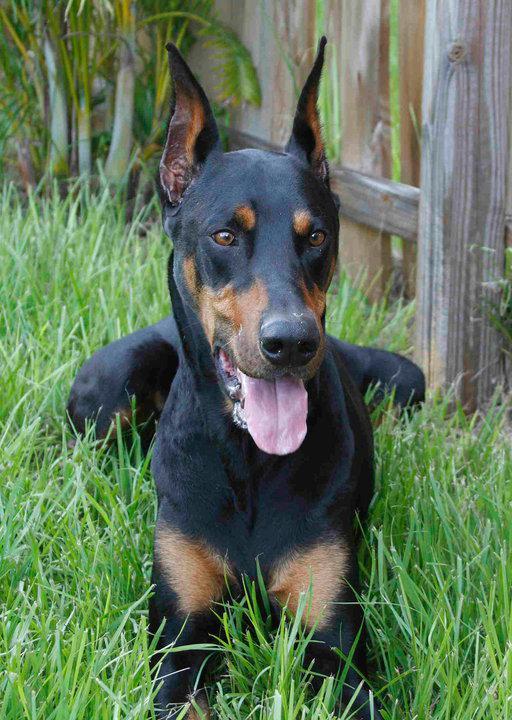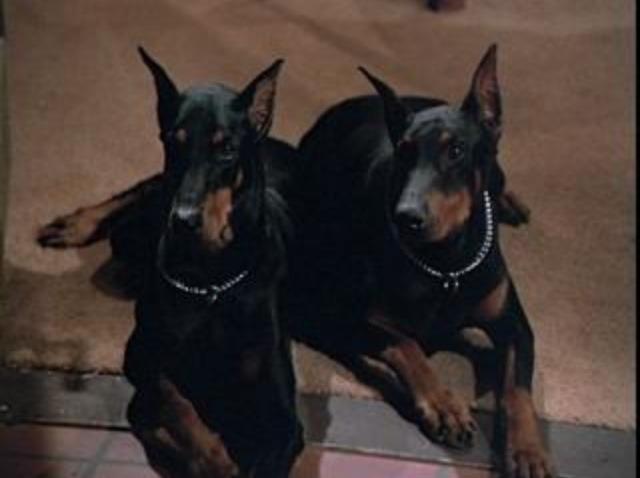The first image is the image on the left, the second image is the image on the right. For the images shown, is this caption "There are at least five dogs." true? Answer yes or no. No. The first image is the image on the left, the second image is the image on the right. Considering the images on both sides, is "There are more dogs in the image on the right" valid? Answer yes or no. Yes. 